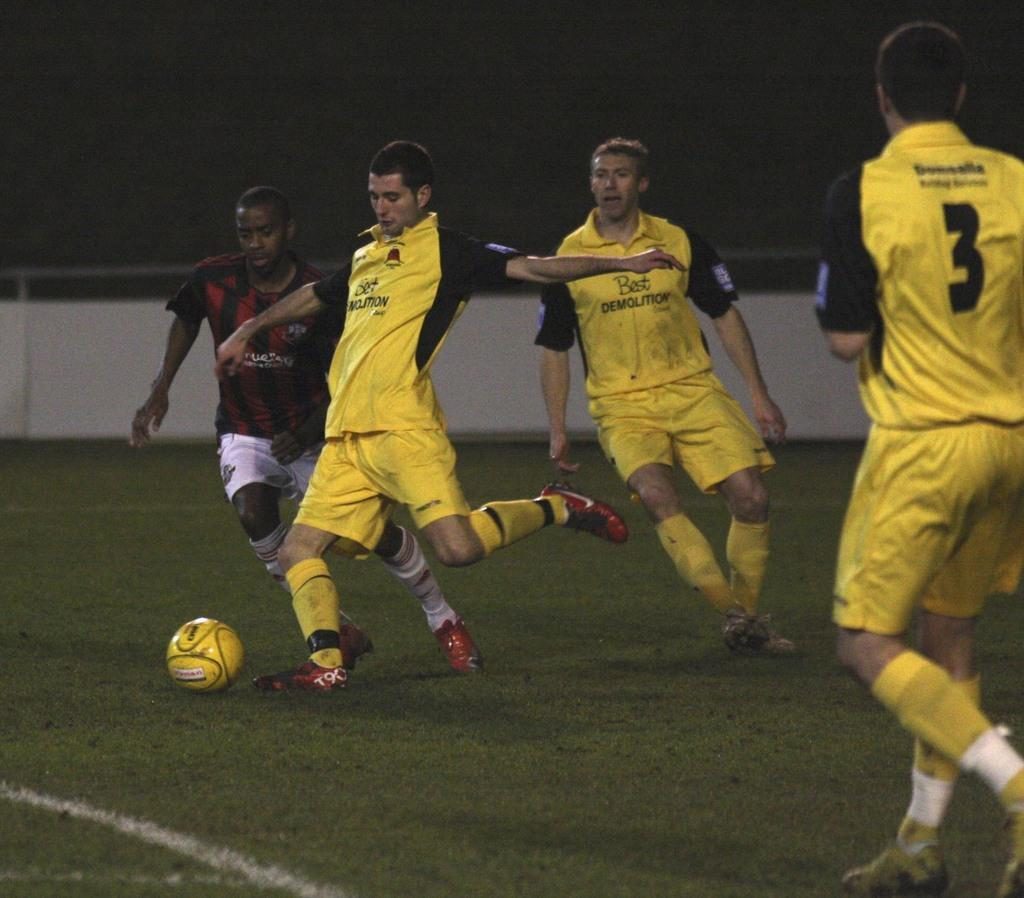<image>
Offer a succinct explanation of the picture presented. sports men playing soccer in jerseys reading Best Demolition 